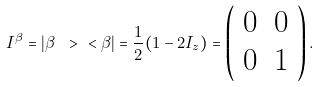Convert formula to latex. <formula><loc_0><loc_0><loc_500><loc_500>I ^ { \beta } = | \beta \ > \ < \beta | = \frac { 1 } { 2 } ( 1 - 2 I _ { z } ) = \left ( \begin{array} { c c } 0 & 0 \\ 0 & 1 \end{array} \right ) .</formula> 